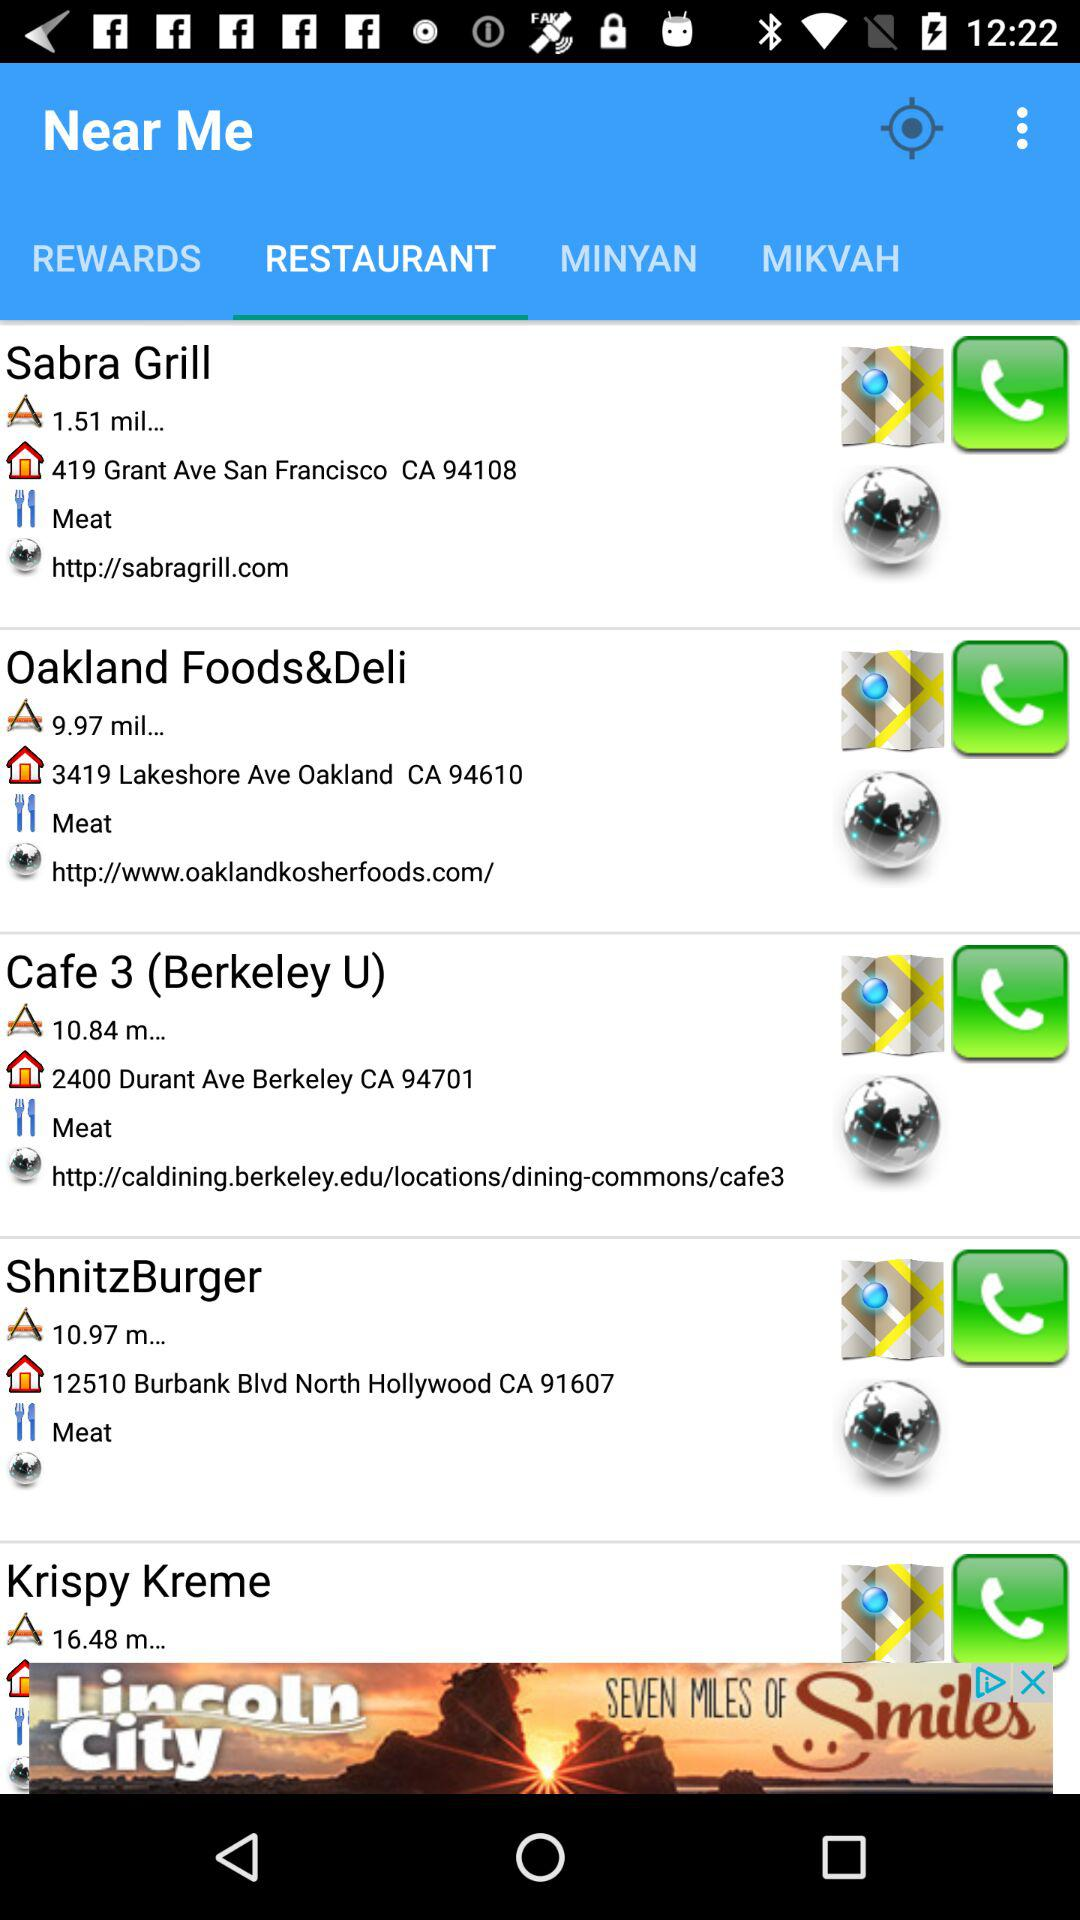How much distance will be covered to reach Sabra Grill? The distance covered will be "1.51 mil...". 